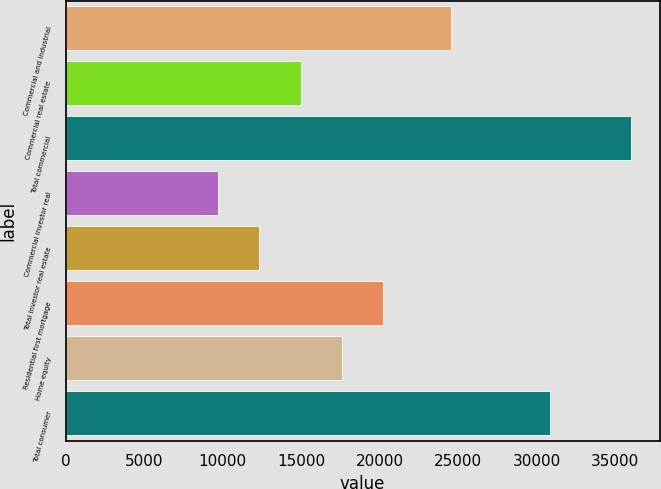Convert chart. <chart><loc_0><loc_0><loc_500><loc_500><bar_chart><fcel>Commercial and industrial<fcel>Commercial real estate<fcel>Total commercial<fcel>Commercial investor real<fcel>Total investor real estate<fcel>Residential first mortgage<fcel>Home equity<fcel>Total consumer<nl><fcel>24522<fcel>14966.6<fcel>36025<fcel>9702<fcel>12334.3<fcel>20231.2<fcel>17598.9<fcel>30842<nl></chart> 